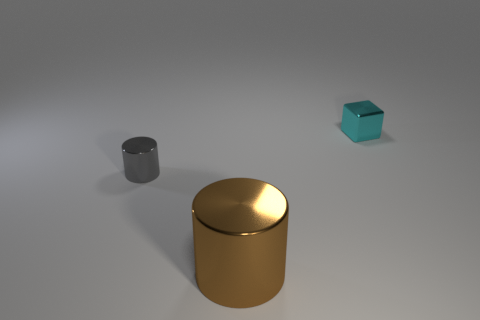How many gray cylinders are made of the same material as the gray object?
Your answer should be compact. 0. What number of objects are either large brown cylinders or small metallic things in front of the block?
Give a very brief answer. 2. There is a cylinder right of the tiny thing in front of the small shiny thing behind the small cylinder; what is its color?
Offer a very short reply. Brown. How big is the metallic cylinder that is to the left of the brown metallic cylinder?
Offer a very short reply. Small. How many large things are either metallic blocks or red matte cylinders?
Make the answer very short. 0. There is a object that is in front of the small cyan shiny thing and behind the large thing; what color is it?
Offer a terse response. Gray. Is there another cyan thing that has the same shape as the small cyan metal thing?
Ensure brevity in your answer.  No. What material is the gray object?
Ensure brevity in your answer.  Metal. There is a cyan metal thing; are there any gray metallic objects behind it?
Your answer should be very brief. No. Do the cyan object and the gray shiny thing have the same shape?
Your response must be concise. No. 